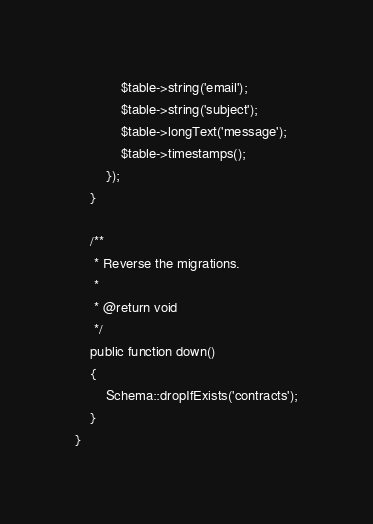<code> <loc_0><loc_0><loc_500><loc_500><_PHP_>            $table->string('email');
            $table->string('subject');
            $table->longText('message');
            $table->timestamps();
        });
    }

    /**
     * Reverse the migrations.
     *
     * @return void
     */
    public function down()
    {
        Schema::dropIfExists('contracts');
    }
}
</code> 